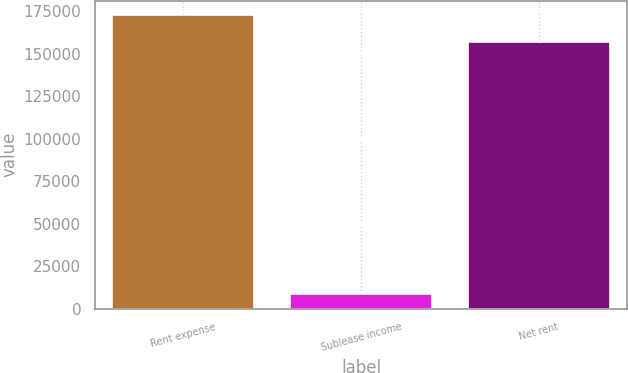Convert chart to OTSL. <chart><loc_0><loc_0><loc_500><loc_500><bar_chart><fcel>Rent expense<fcel>Sublease income<fcel>Net rent<nl><fcel>172501<fcel>8402<fcel>156819<nl></chart> 